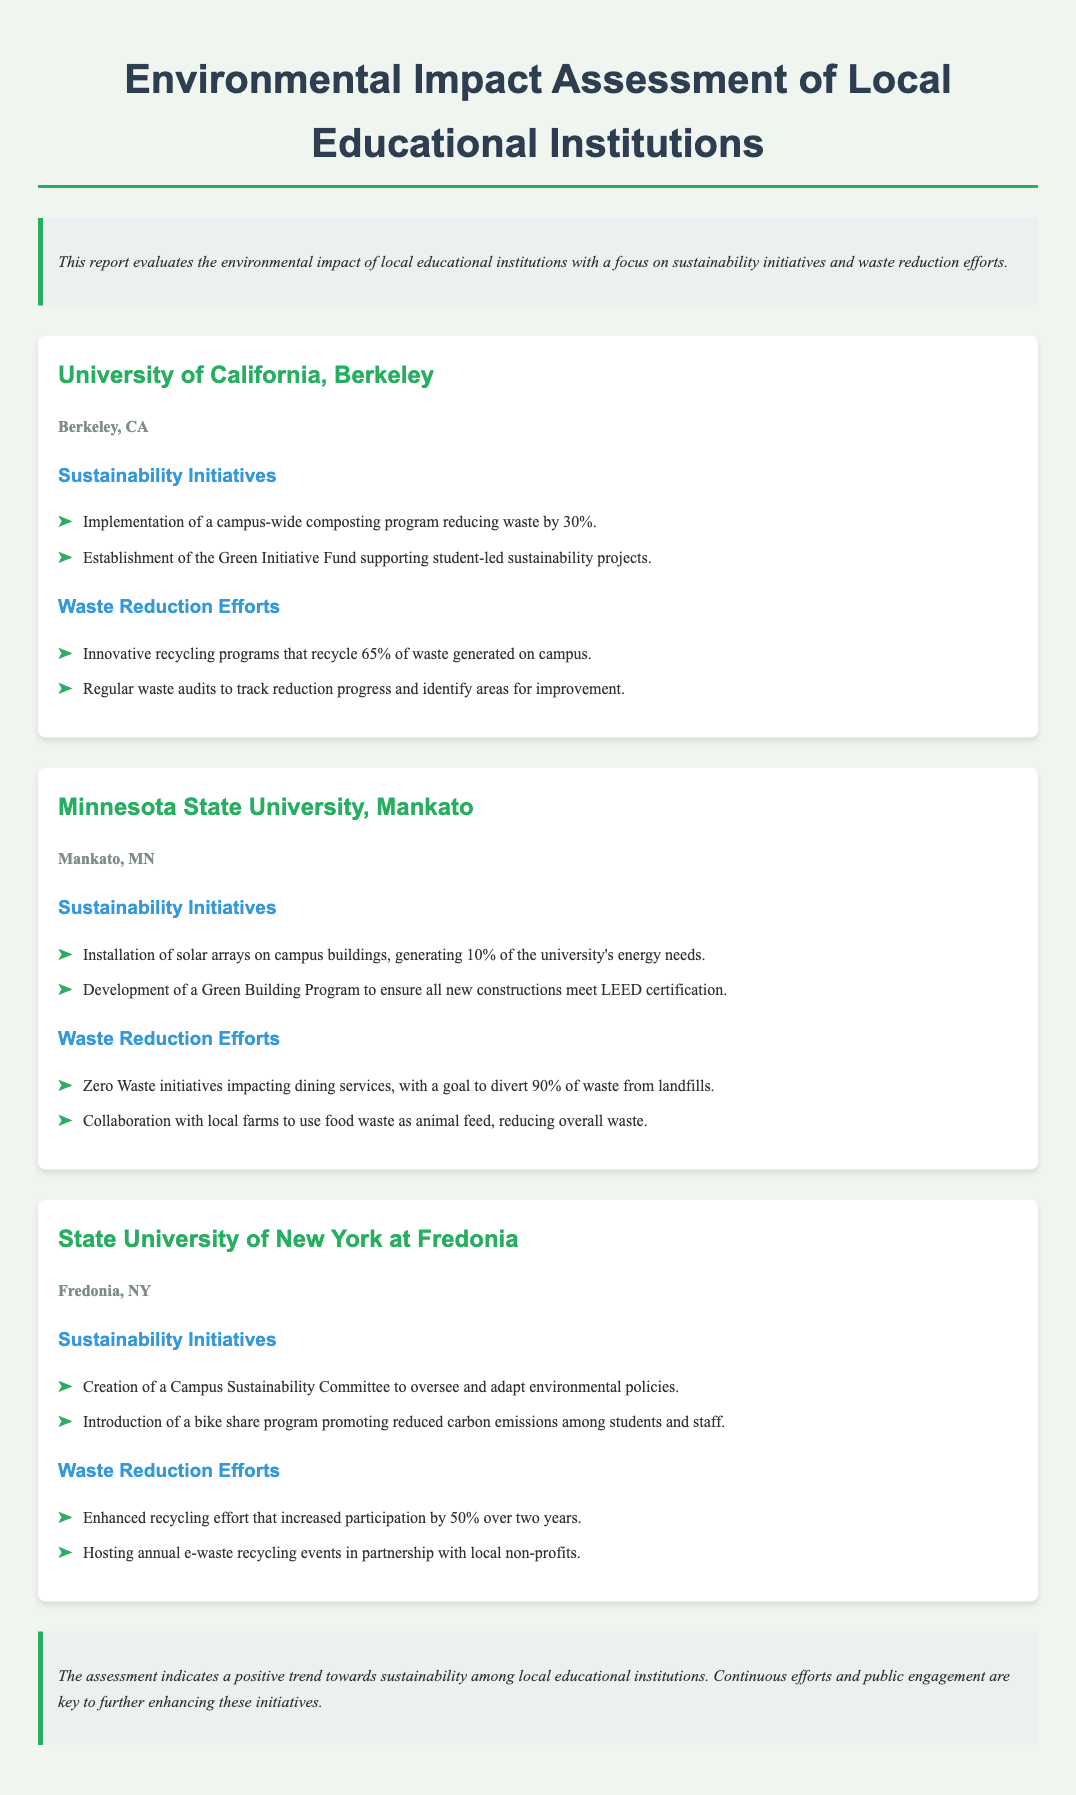What is the title of the report? The title is stated at the top of the document, summarizing the content it evaluates.
Answer: Environmental Impact Assessment of Local Educational Institutions Which university is implementing a composting program? The composting program is specifically mentioned in the sustainability initiatives section for a particular institution.
Answer: University of California, Berkeley What percentage of energy needs is generated by solar arrays at Minnesota State University, Mankato? The document provides this specific information under the sustainability initiatives for Minnesota State University, Mankato.
Answer: 10% What initiative aims to divert 90% of waste from landfills at Minnesota State University, Mankato? The document names this initiative under the waste reduction efforts of the institution.
Answer: Zero Waste initiatives How much did participation in recycling increase at State University of New York at Fredonia? The increase in participation is mentioned as part of their waste reduction efforts.
Answer: 50% What is the goal of the Green Initiative Fund? The purpose of this fund is described to support specific types of projects at the university.
Answer: Student-led sustainability projects What did the Campus Sustainability Committee oversee? This committee's role is specified in relation to the institution's environmental policies.
Answer: Environmental policies What type of events are hosted annually at State University of New York at Fredonia? The document discusses events organized for a particular purpose related to waste management.
Answer: E-waste recycling events 